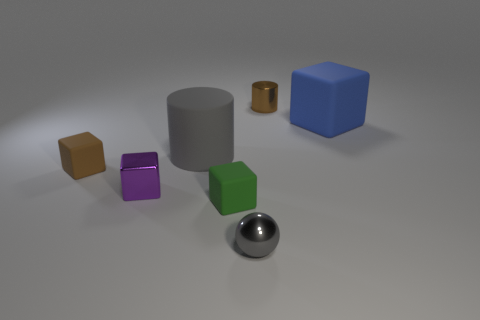Do the matte thing on the left side of the big matte cylinder and the metallic cylinder have the same color?
Offer a very short reply. Yes. What number of other things are there of the same size as the blue rubber thing?
Offer a terse response. 1. There is a thing that is the same color as the shiny cylinder; what size is it?
Your response must be concise. Small. There is a cylinder that is in front of the metal thing on the right side of the tiny gray shiny sphere; what is it made of?
Provide a short and direct response. Rubber. Are there any large blue matte objects to the left of the small brown metal thing?
Keep it short and to the point. No. Is the number of gray things in front of the gray matte thing greater than the number of small brown metallic blocks?
Provide a short and direct response. Yes. Are there any other tiny shiny spheres that have the same color as the tiny sphere?
Keep it short and to the point. No. There is a rubber object that is the same size as the matte cylinder; what color is it?
Your answer should be compact. Blue. Are there any things that are behind the rubber block on the right side of the small green rubber block?
Provide a short and direct response. Yes. There is a small purple cube behind the tiny gray metal sphere; what is its material?
Give a very brief answer. Metal. 